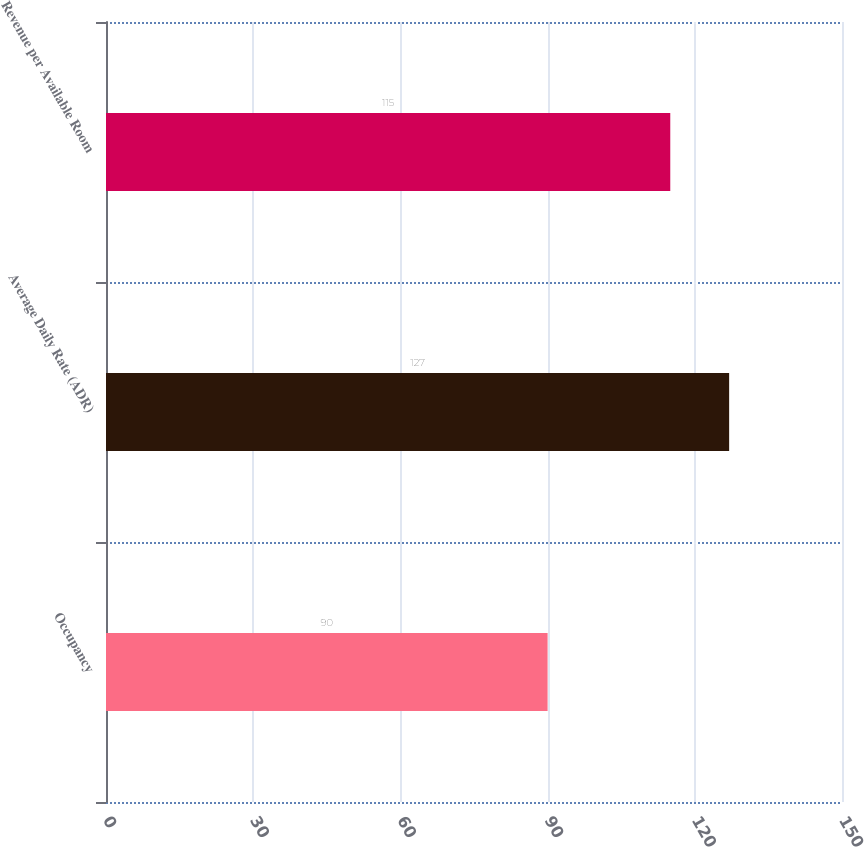Convert chart to OTSL. <chart><loc_0><loc_0><loc_500><loc_500><bar_chart><fcel>Occupancy<fcel>Average Daily Rate (ADR)<fcel>Revenue per Available Room<nl><fcel>90<fcel>127<fcel>115<nl></chart> 